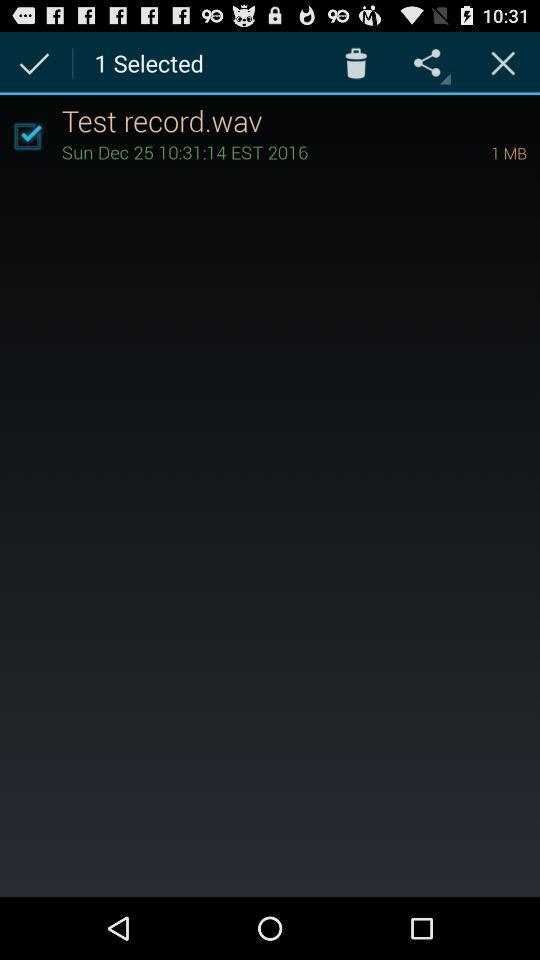What is the date of "Test record.wav"? The date of "Test record.wav" is Sunday, December 25. 